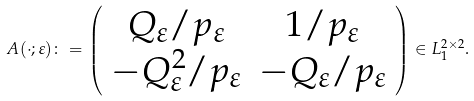Convert formula to latex. <formula><loc_0><loc_0><loc_500><loc_500>A ( \cdot ; \varepsilon ) \colon = \left ( \begin{array} { c c } Q _ { \varepsilon } / p _ { \varepsilon } & 1 / p _ { \varepsilon } \\ - Q ^ { 2 } _ { \varepsilon } / p _ { \varepsilon } & - Q _ { \varepsilon } / p _ { \varepsilon } \end{array} \right ) \in L _ { 1 } ^ { 2 \times 2 } .</formula> 